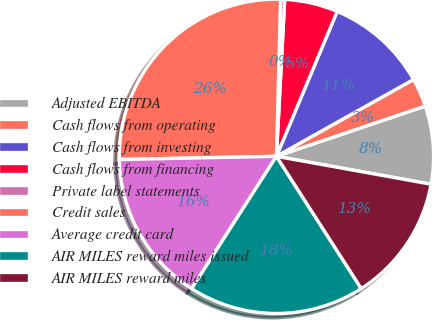Convert chart to OTSL. <chart><loc_0><loc_0><loc_500><loc_500><pie_chart><fcel>Adjusted EBITDA<fcel>Cash flows from operating<fcel>Cash flows from investing<fcel>Cash flows from financing<fcel>Private label statements<fcel>Credit sales<fcel>Average credit card<fcel>AIR MILES reward miles issued<fcel>AIR MILES reward miles<nl><fcel>8.02%<fcel>2.95%<fcel>10.55%<fcel>5.48%<fcel>0.42%<fcel>25.74%<fcel>15.61%<fcel>18.14%<fcel>13.08%<nl></chart> 